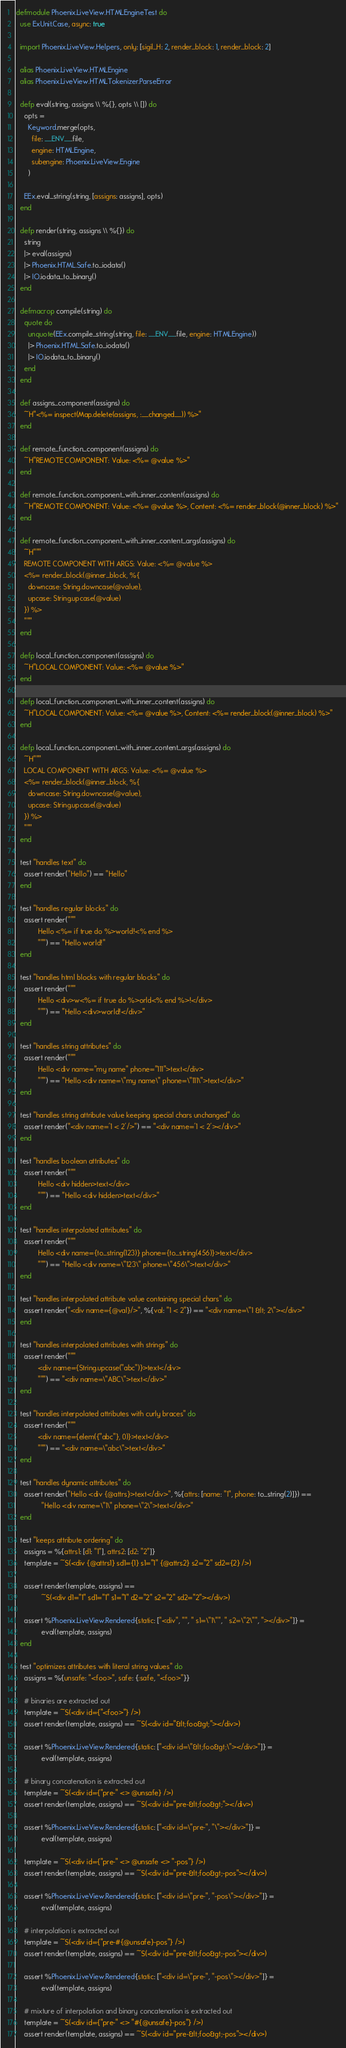Convert code to text. <code><loc_0><loc_0><loc_500><loc_500><_Elixir_>defmodule Phoenix.LiveView.HTMLEngineTest do
  use ExUnit.Case, async: true

  import Phoenix.LiveView.Helpers, only: [sigil_H: 2, render_block: 1, render_block: 2]

  alias Phoenix.LiveView.HTMLEngine
  alias Phoenix.LiveView.HTMLTokenizer.ParseError

  defp eval(string, assigns \\ %{}, opts \\ []) do
    opts =
      Keyword.merge(opts,
        file: __ENV__.file,
        engine: HTMLEngine,
        subengine: Phoenix.LiveView.Engine
      )

    EEx.eval_string(string, [assigns: assigns], opts)
  end

  defp render(string, assigns \\ %{}) do
    string
    |> eval(assigns)
    |> Phoenix.HTML.Safe.to_iodata()
    |> IO.iodata_to_binary()
  end

  defmacrop compile(string) do
    quote do
      unquote(EEx.compile_string(string, file: __ENV__.file, engine: HTMLEngine))
      |> Phoenix.HTML.Safe.to_iodata()
      |> IO.iodata_to_binary()
    end
  end

  def assigns_component(assigns) do
    ~H"<%= inspect(Map.delete(assigns, :__changed__)) %>"
  end

  def remote_function_component(assigns) do
    ~H"REMOTE COMPONENT: Value: <%= @value %>"
  end

  def remote_function_component_with_inner_content(assigns) do
    ~H"REMOTE COMPONENT: Value: <%= @value %>, Content: <%= render_block(@inner_block) %>"
  end

  def remote_function_component_with_inner_content_args(assigns) do
    ~H"""
    REMOTE COMPONENT WITH ARGS: Value: <%= @value %>
    <%= render_block(@inner_block, %{
      downcase: String.downcase(@value),
      upcase: String.upcase(@value)
    }) %>
    """
  end

  defp local_function_component(assigns) do
    ~H"LOCAL COMPONENT: Value: <%= @value %>"
  end

  defp local_function_component_with_inner_content(assigns) do
    ~H"LOCAL COMPONENT: Value: <%= @value %>, Content: <%= render_block(@inner_block) %>"
  end

  defp local_function_component_with_inner_content_args(assigns) do
    ~H"""
    LOCAL COMPONENT WITH ARGS: Value: <%= @value %>
    <%= render_block(@inner_block, %{
      downcase: String.downcase(@value),
      upcase: String.upcase(@value)
    }) %>
    """
  end

  test "handles text" do
    assert render("Hello") == "Hello"
  end

  test "handles regular blocks" do
    assert render("""
           Hello <%= if true do %>world!<% end %>
           """) == "Hello world!"
  end

  test "handles html blocks with regular blocks" do
    assert render("""
           Hello <div>w<%= if true do %>orld<% end %>!</div>
           """) == "Hello <div>world!</div>"
  end

  test "handles string attributes" do
    assert render("""
           Hello <div name="my name" phone="111">text</div>
           """) == "Hello <div name=\"my name\" phone=\"111\">text</div>"
  end

  test "handles string attribute value keeping special chars unchanged" do
    assert render("<div name='1 < 2'/>") == "<div name='1 < 2'></div>"
  end

  test "handles boolean attributes" do
    assert render("""
           Hello <div hidden>text</div>
           """) == "Hello <div hidden>text</div>"
  end

  test "handles interpolated attributes" do
    assert render("""
           Hello <div name={to_string(123)} phone={to_string(456)}>text</div>
           """) == "Hello <div name=\"123\" phone=\"456\">text</div>"
  end

  test "handles interpolated attribute value containing special chars" do
    assert render("<div name={@val}/>", %{val: "1 < 2"}) == "<div name=\"1 &lt; 2\"></div>"
  end

  test "handles interpolated attributes with strings" do
    assert render("""
           <div name={String.upcase("abc")}>text</div>
           """) == "<div name=\"ABC\">text</div>"
  end

  test "handles interpolated attributes with curly braces" do
    assert render("""
           <div name={elem({"abc"}, 0)}>text</div>
           """) == "<div name=\"abc\">text</div>"
  end

  test "handles dynamic attributes" do
    assert render("Hello <div {@attrs}>text</div>", %{attrs: [name: "1", phone: to_string(2)]}) ==
             "Hello <div name=\"1\" phone=\"2\">text</div>"
  end

  test "keeps attribute ordering" do
    assigns = %{attrs1: [d1: "1"], attrs2: [d2: "2"]}
    template = ~S(<div {@attrs1} sd1={1} s1="1" {@attrs2} s2="2" sd2={2} />)

    assert render(template, assigns) ==
             ~S(<div d1="1" sd1="1" s1="1" d2="2" s2="2" sd2="2"></div>)

    assert %Phoenix.LiveView.Rendered{static: ["<div", "", " s1=\"1\"", " s2=\"2\"", "></div>"]} =
             eval(template, assigns)
  end

  test "optimizes attributes with literal string values" do
    assigns = %{unsafe: "<foo>", safe: {:safe, "<foo>"}}

    # binaries are extracted out
    template = ~S(<div id={"<foo>"} />)
    assert render(template, assigns) == ~S(<div id="&lt;foo&gt;"></div>)

    assert %Phoenix.LiveView.Rendered{static: ["<div id=\"&lt;foo&gt;\"></div>"]} =
             eval(template, assigns)

    # binary concatenation is extracted out
    template = ~S(<div id={"pre-" <> @unsafe} />)
    assert render(template, assigns) == ~S(<div id="pre-&lt;foo&gt;"></div>)

    assert %Phoenix.LiveView.Rendered{static: ["<div id=\"pre-", "\"></div>"]} =
             eval(template, assigns)

    template = ~S(<div id={"pre-" <> @unsafe <> "-pos"} />)
    assert render(template, assigns) == ~S(<div id="pre-&lt;foo&gt;-pos"></div>)

    assert %Phoenix.LiveView.Rendered{static: ["<div id=\"pre-", "-pos\"></div>"]} =
             eval(template, assigns)

    # interpolation is extracted out
    template = ~S(<div id={"pre-#{@unsafe}-pos"} />)
    assert render(template, assigns) == ~S(<div id="pre-&lt;foo&gt;-pos"></div>)

    assert %Phoenix.LiveView.Rendered{static: ["<div id=\"pre-", "-pos\"></div>"]} =
             eval(template, assigns)

    # mixture of interpolation and binary concatenation is extracted out
    template = ~S(<div id={"pre-" <> "#{@unsafe}-pos"} />)
    assert render(template, assigns) == ~S(<div id="pre-&lt;foo&gt;-pos"></div>)
</code> 